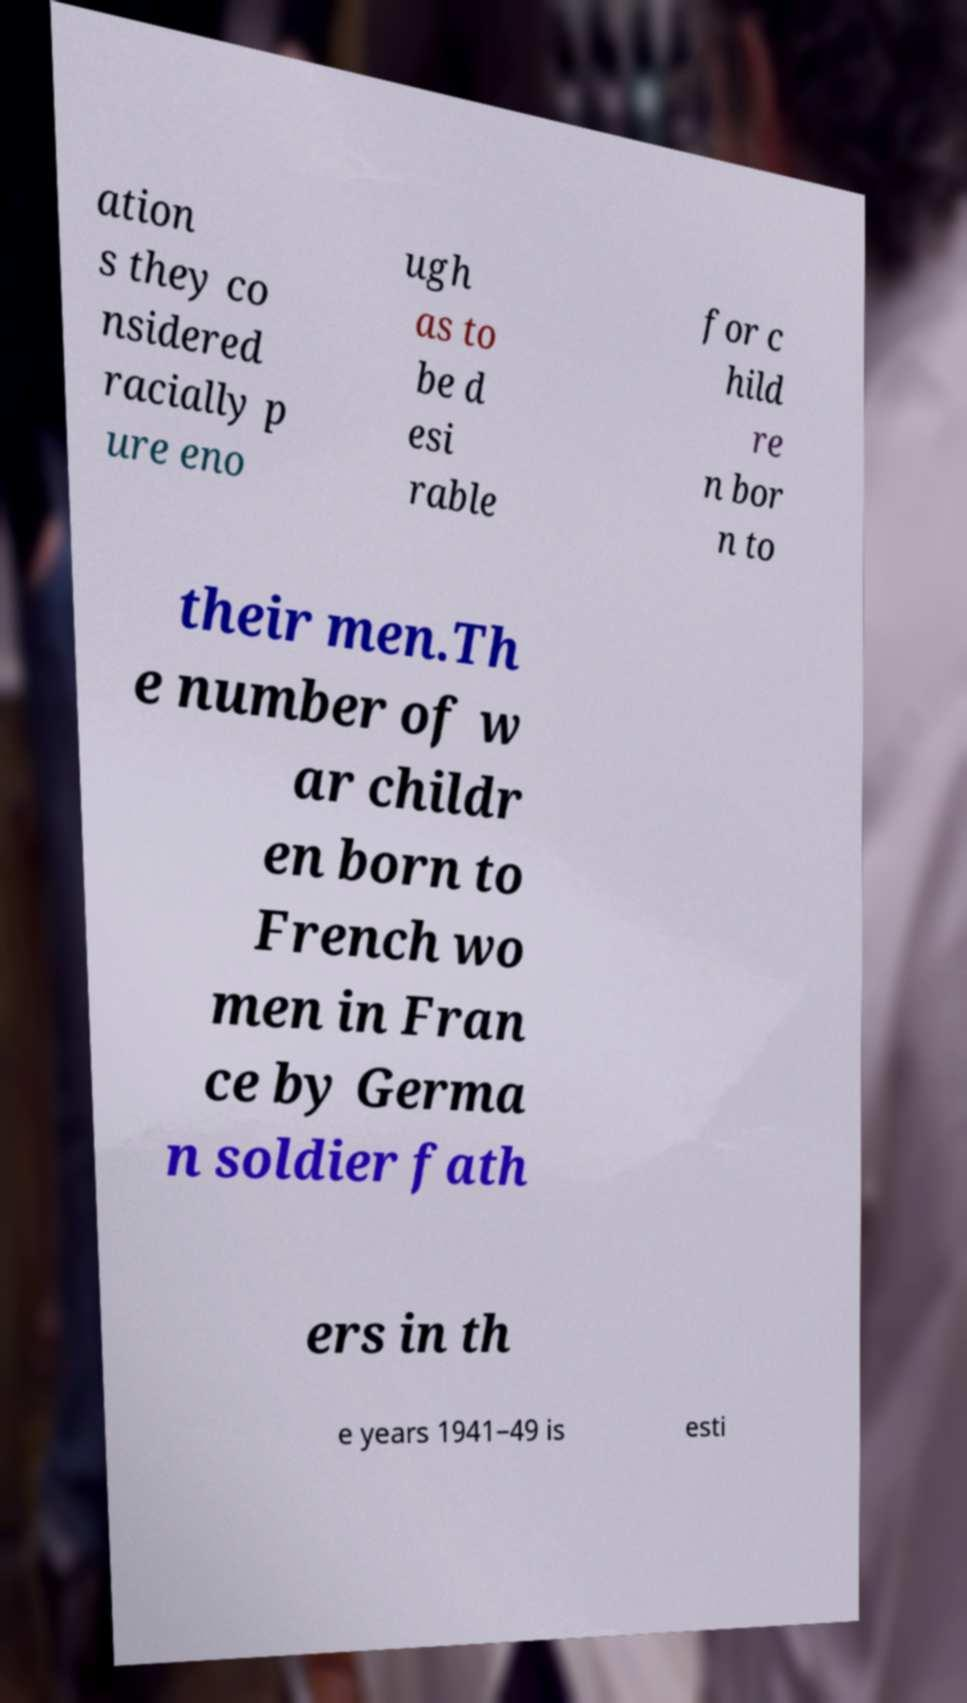Please read and relay the text visible in this image. What does it say? ation s they co nsidered racially p ure eno ugh as to be d esi rable for c hild re n bor n to their men.Th e number of w ar childr en born to French wo men in Fran ce by Germa n soldier fath ers in th e years 1941–49 is esti 